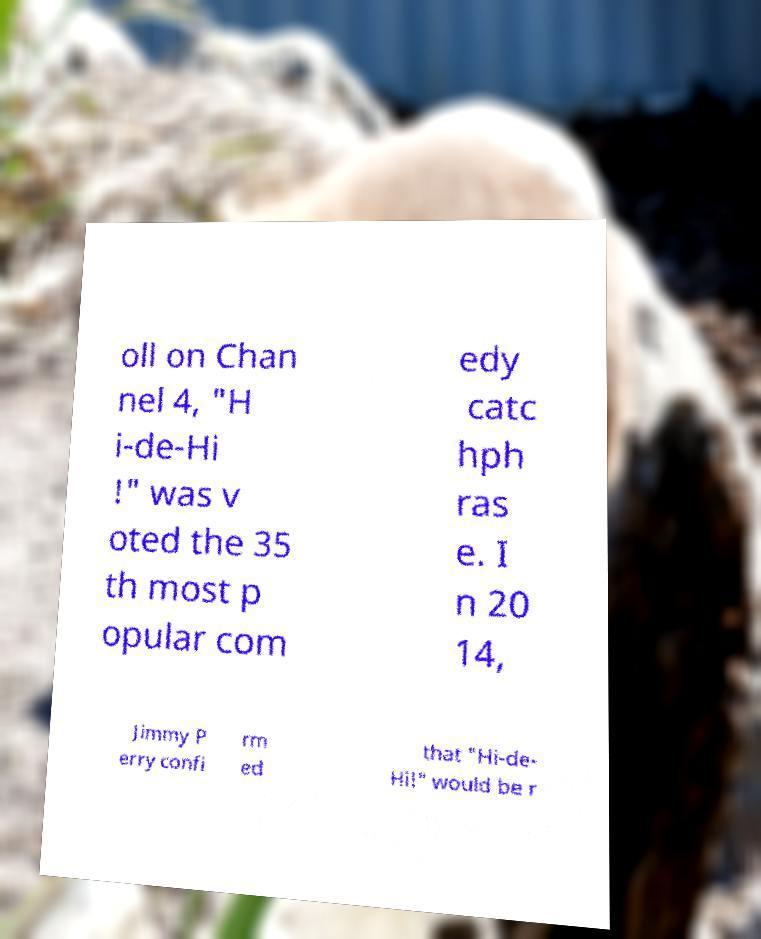I need the written content from this picture converted into text. Can you do that? oll on Chan nel 4, "H i-de-Hi !" was v oted the 35 th most p opular com edy catc hph ras e. I n 20 14, Jimmy P erry confi rm ed that "Hi-de- Hi!" would be r 